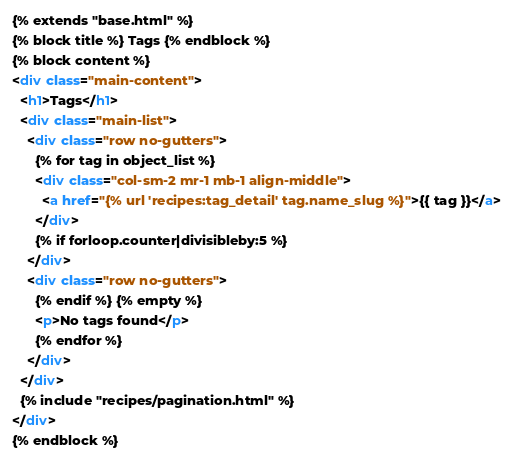Convert code to text. <code><loc_0><loc_0><loc_500><loc_500><_HTML_>{% extends "base.html" %} 
{% block title %} Tags {% endblock %} 
{% block content %}
<div class="main-content">
  <h1>Tags</h1>
  <div class="main-list">
    <div class="row no-gutters">
      {% for tag in object_list %}
      <div class="col-sm-2 mr-1 mb-1 align-middle">
        <a href="{% url 'recipes:tag_detail' tag.name_slug %}">{{ tag }}</a>
      </div>
      {% if forloop.counter|divisibleby:5 %}
    </div>
    <div class="row no-gutters">
      {% endif %} {% empty %}
      <p>No tags found</p>
      {% endfor %}
    </div>
  </div>
  {% include "recipes/pagination.html" %}
</div>
{% endblock %}
</code> 